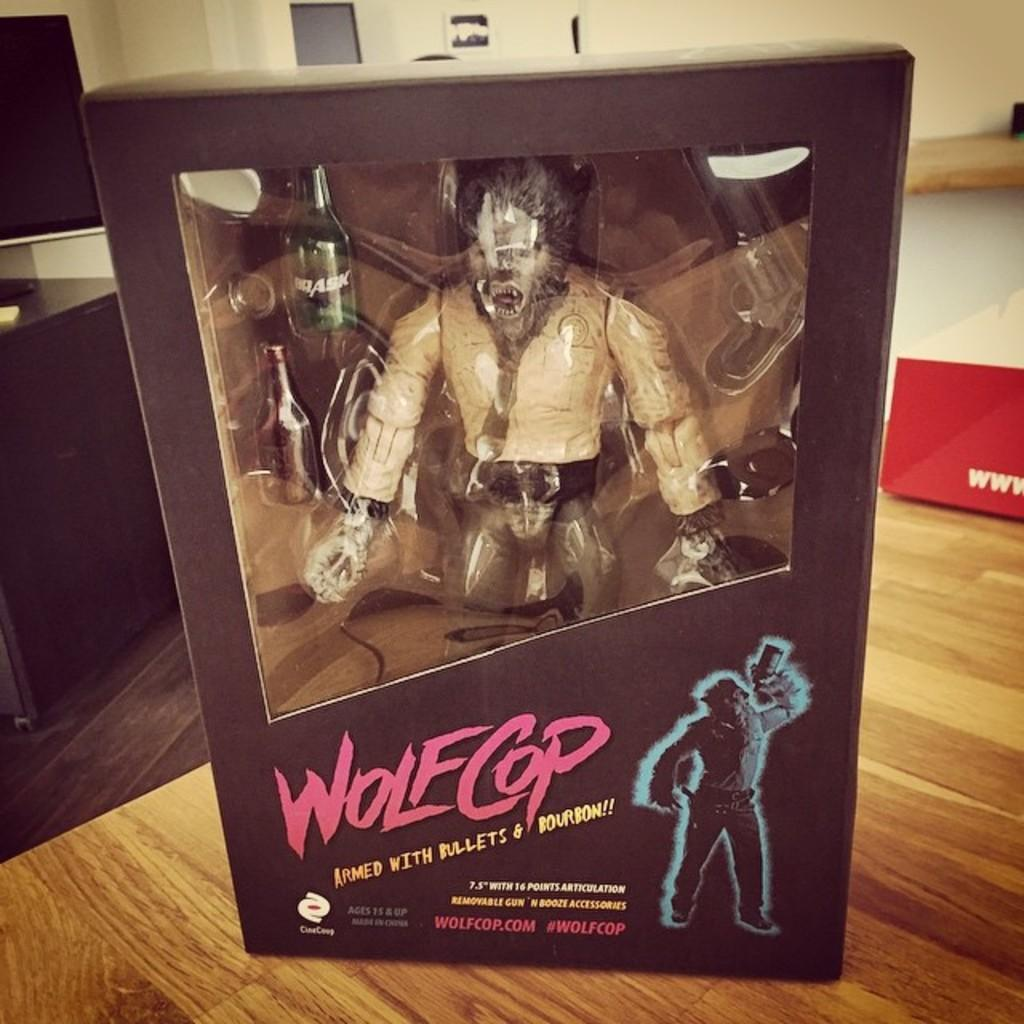<image>
Render a clear and concise summary of the photo. a toy in a box reading Wolf COP on top a wood surface 